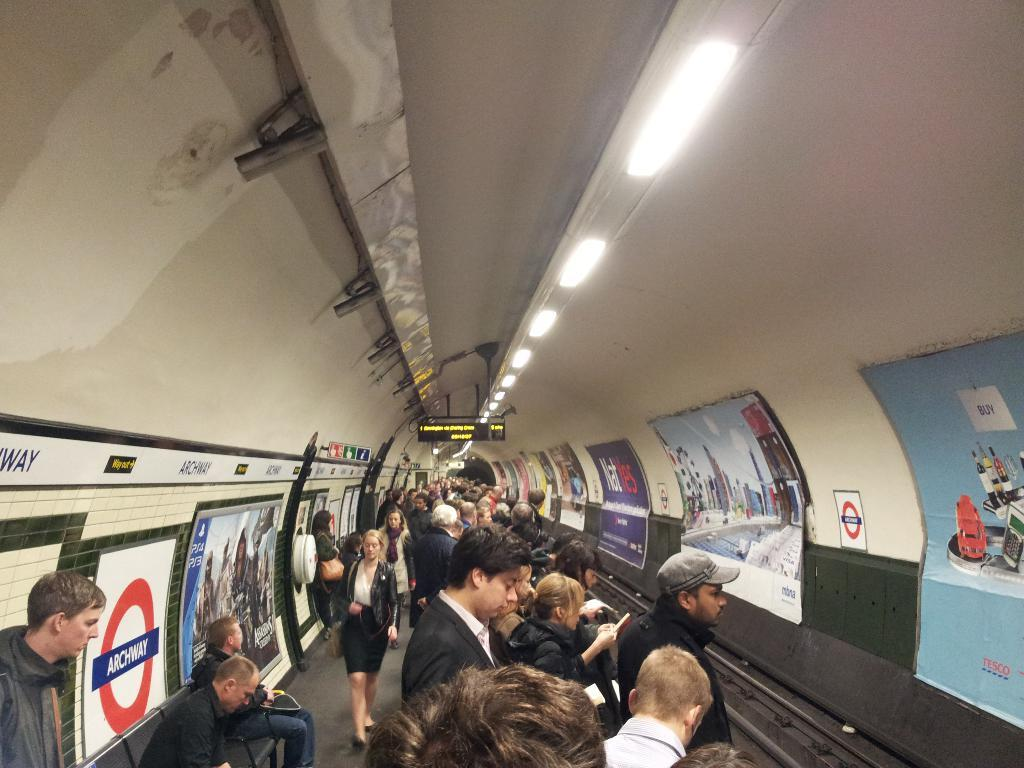Who or what can be seen in the image? There are people in the image. What type of objects are present in the image? There are posters, boards, a mesh, and a screen in the image. Are there any light sources visible in the image? Yes, there are lights visible in the image. What type of slope can be seen in the image? There is no slope present in the image. What kind of feast is being prepared in the image? There is no feast preparation visible in the image. 